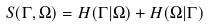Convert formula to latex. <formula><loc_0><loc_0><loc_500><loc_500>S ( \Gamma , \Omega ) = H ( \Gamma | \Omega ) + H ( \Omega | \Gamma )</formula> 